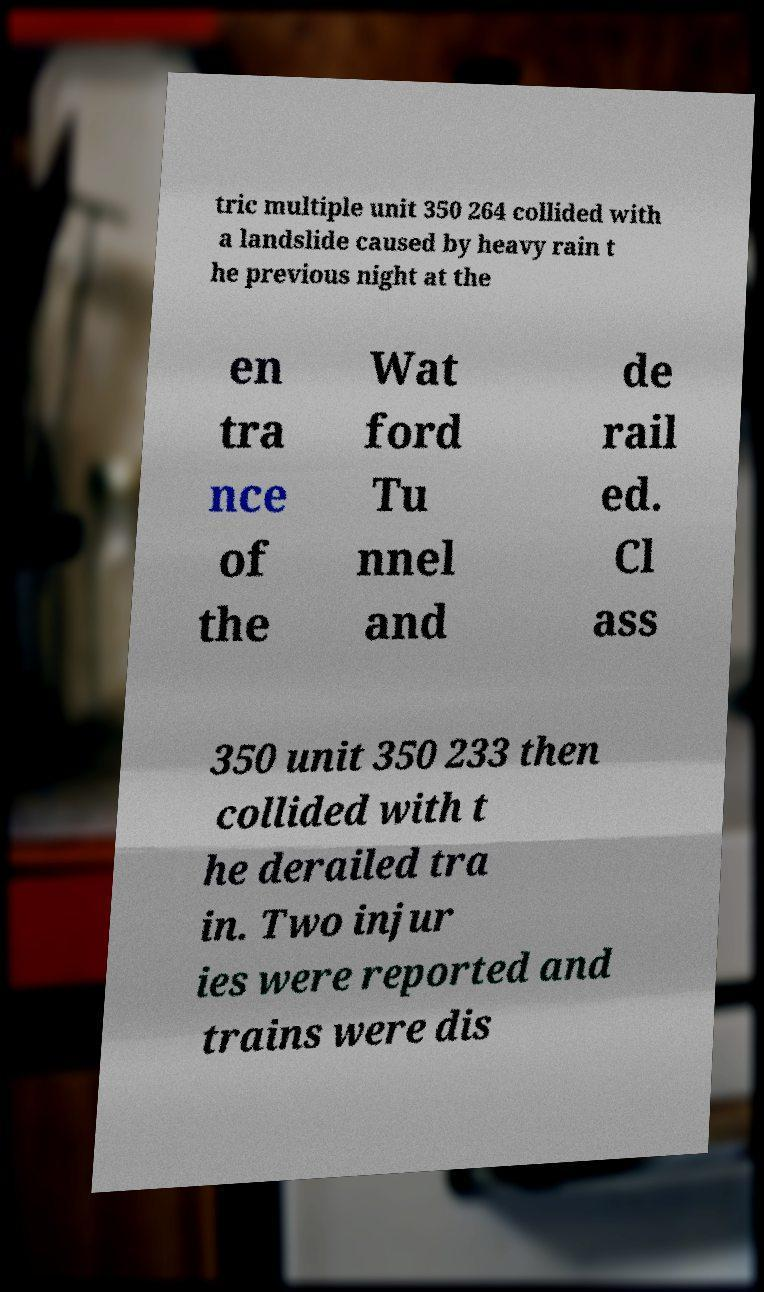I need the written content from this picture converted into text. Can you do that? tric multiple unit 350 264 collided with a landslide caused by heavy rain t he previous night at the en tra nce of the Wat ford Tu nnel and de rail ed. Cl ass 350 unit 350 233 then collided with t he derailed tra in. Two injur ies were reported and trains were dis 